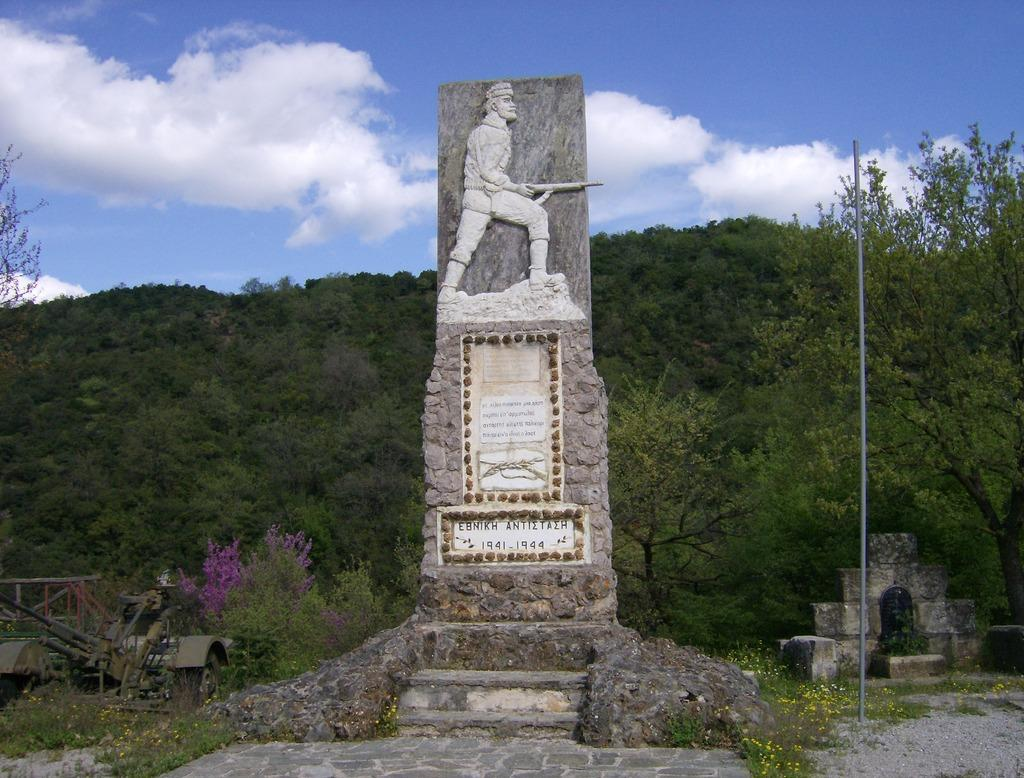What is the main subject of the image? The main subject of the image is a sculpture on a rock. What type of ground is visible in the image? There are laid stones and grass visible in the image. What type of structures can be seen in the image? There are grave stones and a pole in the image. What type of vehicle is present in the image? There is a motor vehicle on the ground in the image. What type of natural elements are present in the image? There are flowers, plants, trees, and the sky visible in the image. What is the condition of the sky in the image? The sky is visible in the image, and there are clouds present. How many babies are present in the image? There are no babies present in the image. What type of market can be seen in the background of the image? There is no market present in the image. 